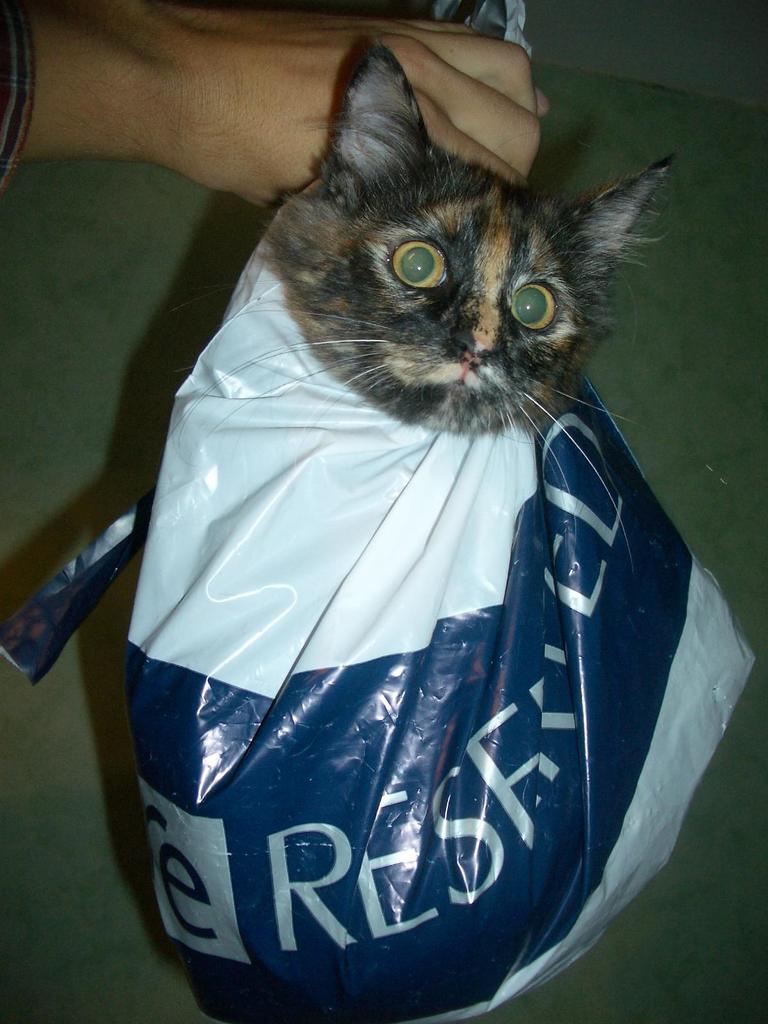Describe this image in one or two sentences. In this image I can see the cat in the plastic cover and the cat is in black and brown color and I can also see the person's hand. 